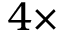Convert formula to latex. <formula><loc_0><loc_0><loc_500><loc_500>4 \times</formula> 